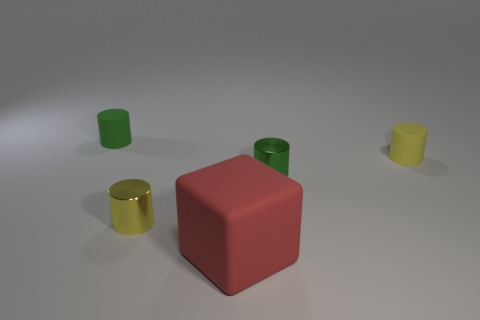The yellow shiny thing that is the same shape as the small green matte object is what size?
Your answer should be compact. Small. There is a large thing; are there any metallic things right of it?
Make the answer very short. Yes. What material is the large red block?
Your answer should be compact. Rubber. Is there any other thing that has the same shape as the tiny green matte thing?
Your response must be concise. Yes. There is another metal thing that is the same shape as the yellow shiny object; what color is it?
Your answer should be compact. Green. What is the material of the tiny green thing that is on the left side of the big red block?
Make the answer very short. Rubber. The block is what color?
Give a very brief answer. Red. There is a yellow metal thing behind the rubber block; does it have the same size as the tiny green matte object?
Your response must be concise. Yes. There is a green cylinder that is on the right side of the object that is in front of the tiny yellow cylinder to the left of the tiny yellow rubber cylinder; what is its material?
Make the answer very short. Metal. There is a tiny matte thing that is left of the yellow rubber object; is its color the same as the shiny object behind the tiny yellow metal cylinder?
Make the answer very short. Yes. 